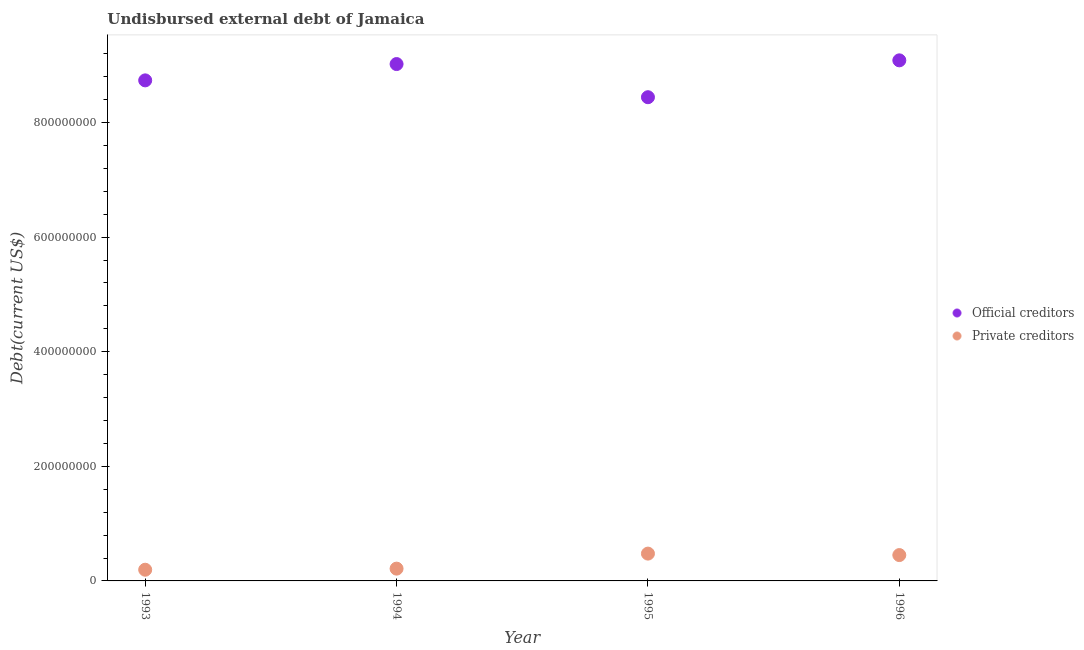How many different coloured dotlines are there?
Ensure brevity in your answer.  2. Is the number of dotlines equal to the number of legend labels?
Ensure brevity in your answer.  Yes. What is the undisbursed external debt of official creditors in 1994?
Ensure brevity in your answer.  9.02e+08. Across all years, what is the maximum undisbursed external debt of private creditors?
Your response must be concise. 4.77e+07. Across all years, what is the minimum undisbursed external debt of official creditors?
Provide a short and direct response. 8.44e+08. In which year was the undisbursed external debt of private creditors minimum?
Your response must be concise. 1993. What is the total undisbursed external debt of private creditors in the graph?
Make the answer very short. 1.34e+08. What is the difference between the undisbursed external debt of official creditors in 1993 and that in 1994?
Make the answer very short. -2.85e+07. What is the difference between the undisbursed external debt of private creditors in 1993 and the undisbursed external debt of official creditors in 1996?
Provide a short and direct response. -8.89e+08. What is the average undisbursed external debt of official creditors per year?
Offer a terse response. 8.82e+08. In the year 1994, what is the difference between the undisbursed external debt of official creditors and undisbursed external debt of private creditors?
Keep it short and to the point. 8.81e+08. In how many years, is the undisbursed external debt of private creditors greater than 480000000 US$?
Offer a very short reply. 0. What is the ratio of the undisbursed external debt of private creditors in 1994 to that in 1996?
Your answer should be very brief. 0.48. Is the undisbursed external debt of private creditors in 1995 less than that in 1996?
Your answer should be very brief. No. Is the difference between the undisbursed external debt of official creditors in 1994 and 1995 greater than the difference between the undisbursed external debt of private creditors in 1994 and 1995?
Offer a very short reply. Yes. What is the difference between the highest and the second highest undisbursed external debt of private creditors?
Make the answer very short. 2.56e+06. What is the difference between the highest and the lowest undisbursed external debt of official creditors?
Provide a succinct answer. 6.43e+07. Does the undisbursed external debt of official creditors monotonically increase over the years?
Keep it short and to the point. No. Is the undisbursed external debt of official creditors strictly greater than the undisbursed external debt of private creditors over the years?
Your answer should be very brief. Yes. Are the values on the major ticks of Y-axis written in scientific E-notation?
Offer a terse response. No. Does the graph contain any zero values?
Provide a succinct answer. No. Does the graph contain grids?
Your answer should be compact. No. How many legend labels are there?
Make the answer very short. 2. How are the legend labels stacked?
Keep it short and to the point. Vertical. What is the title of the graph?
Offer a terse response. Undisbursed external debt of Jamaica. What is the label or title of the X-axis?
Your answer should be compact. Year. What is the label or title of the Y-axis?
Your response must be concise. Debt(current US$). What is the Debt(current US$) of Official creditors in 1993?
Ensure brevity in your answer.  8.74e+08. What is the Debt(current US$) in Private creditors in 1993?
Your answer should be very brief. 1.95e+07. What is the Debt(current US$) in Official creditors in 1994?
Give a very brief answer. 9.02e+08. What is the Debt(current US$) of Private creditors in 1994?
Ensure brevity in your answer.  2.14e+07. What is the Debt(current US$) of Official creditors in 1995?
Provide a short and direct response. 8.44e+08. What is the Debt(current US$) in Private creditors in 1995?
Your answer should be very brief. 4.77e+07. What is the Debt(current US$) of Official creditors in 1996?
Your response must be concise. 9.09e+08. What is the Debt(current US$) of Private creditors in 1996?
Give a very brief answer. 4.51e+07. Across all years, what is the maximum Debt(current US$) in Official creditors?
Keep it short and to the point. 9.09e+08. Across all years, what is the maximum Debt(current US$) in Private creditors?
Offer a terse response. 4.77e+07. Across all years, what is the minimum Debt(current US$) of Official creditors?
Offer a very short reply. 8.44e+08. Across all years, what is the minimum Debt(current US$) in Private creditors?
Offer a very short reply. 1.95e+07. What is the total Debt(current US$) of Official creditors in the graph?
Your answer should be compact. 3.53e+09. What is the total Debt(current US$) in Private creditors in the graph?
Your response must be concise. 1.34e+08. What is the difference between the Debt(current US$) of Official creditors in 1993 and that in 1994?
Ensure brevity in your answer.  -2.85e+07. What is the difference between the Debt(current US$) of Private creditors in 1993 and that in 1994?
Your response must be concise. -1.91e+06. What is the difference between the Debt(current US$) in Official creditors in 1993 and that in 1995?
Provide a short and direct response. 2.94e+07. What is the difference between the Debt(current US$) in Private creditors in 1993 and that in 1995?
Offer a very short reply. -2.81e+07. What is the difference between the Debt(current US$) of Official creditors in 1993 and that in 1996?
Make the answer very short. -3.50e+07. What is the difference between the Debt(current US$) in Private creditors in 1993 and that in 1996?
Your answer should be compact. -2.56e+07. What is the difference between the Debt(current US$) of Official creditors in 1994 and that in 1995?
Ensure brevity in your answer.  5.79e+07. What is the difference between the Debt(current US$) in Private creditors in 1994 and that in 1995?
Provide a succinct answer. -2.62e+07. What is the difference between the Debt(current US$) in Official creditors in 1994 and that in 1996?
Make the answer very short. -6.48e+06. What is the difference between the Debt(current US$) in Private creditors in 1994 and that in 1996?
Provide a succinct answer. -2.37e+07. What is the difference between the Debt(current US$) of Official creditors in 1995 and that in 1996?
Offer a terse response. -6.43e+07. What is the difference between the Debt(current US$) of Private creditors in 1995 and that in 1996?
Ensure brevity in your answer.  2.56e+06. What is the difference between the Debt(current US$) of Official creditors in 1993 and the Debt(current US$) of Private creditors in 1994?
Make the answer very short. 8.52e+08. What is the difference between the Debt(current US$) of Official creditors in 1993 and the Debt(current US$) of Private creditors in 1995?
Make the answer very short. 8.26e+08. What is the difference between the Debt(current US$) in Official creditors in 1993 and the Debt(current US$) in Private creditors in 1996?
Offer a terse response. 8.29e+08. What is the difference between the Debt(current US$) of Official creditors in 1994 and the Debt(current US$) of Private creditors in 1995?
Offer a very short reply. 8.54e+08. What is the difference between the Debt(current US$) of Official creditors in 1994 and the Debt(current US$) of Private creditors in 1996?
Your answer should be very brief. 8.57e+08. What is the difference between the Debt(current US$) of Official creditors in 1995 and the Debt(current US$) of Private creditors in 1996?
Provide a succinct answer. 7.99e+08. What is the average Debt(current US$) in Official creditors per year?
Provide a succinct answer. 8.82e+08. What is the average Debt(current US$) in Private creditors per year?
Give a very brief answer. 3.34e+07. In the year 1993, what is the difference between the Debt(current US$) in Official creditors and Debt(current US$) in Private creditors?
Provide a succinct answer. 8.54e+08. In the year 1994, what is the difference between the Debt(current US$) in Official creditors and Debt(current US$) in Private creditors?
Provide a short and direct response. 8.81e+08. In the year 1995, what is the difference between the Debt(current US$) in Official creditors and Debt(current US$) in Private creditors?
Ensure brevity in your answer.  7.97e+08. In the year 1996, what is the difference between the Debt(current US$) in Official creditors and Debt(current US$) in Private creditors?
Give a very brief answer. 8.63e+08. What is the ratio of the Debt(current US$) of Official creditors in 1993 to that in 1994?
Provide a succinct answer. 0.97. What is the ratio of the Debt(current US$) of Private creditors in 1993 to that in 1994?
Your response must be concise. 0.91. What is the ratio of the Debt(current US$) in Official creditors in 1993 to that in 1995?
Give a very brief answer. 1.03. What is the ratio of the Debt(current US$) of Private creditors in 1993 to that in 1995?
Ensure brevity in your answer.  0.41. What is the ratio of the Debt(current US$) in Official creditors in 1993 to that in 1996?
Provide a short and direct response. 0.96. What is the ratio of the Debt(current US$) of Private creditors in 1993 to that in 1996?
Your answer should be compact. 0.43. What is the ratio of the Debt(current US$) in Official creditors in 1994 to that in 1995?
Your answer should be very brief. 1.07. What is the ratio of the Debt(current US$) in Private creditors in 1994 to that in 1995?
Offer a very short reply. 0.45. What is the ratio of the Debt(current US$) of Official creditors in 1994 to that in 1996?
Make the answer very short. 0.99. What is the ratio of the Debt(current US$) in Private creditors in 1994 to that in 1996?
Make the answer very short. 0.48. What is the ratio of the Debt(current US$) in Official creditors in 1995 to that in 1996?
Your answer should be compact. 0.93. What is the ratio of the Debt(current US$) of Private creditors in 1995 to that in 1996?
Offer a very short reply. 1.06. What is the difference between the highest and the second highest Debt(current US$) in Official creditors?
Make the answer very short. 6.48e+06. What is the difference between the highest and the second highest Debt(current US$) in Private creditors?
Your answer should be compact. 2.56e+06. What is the difference between the highest and the lowest Debt(current US$) in Official creditors?
Give a very brief answer. 6.43e+07. What is the difference between the highest and the lowest Debt(current US$) in Private creditors?
Ensure brevity in your answer.  2.81e+07. 